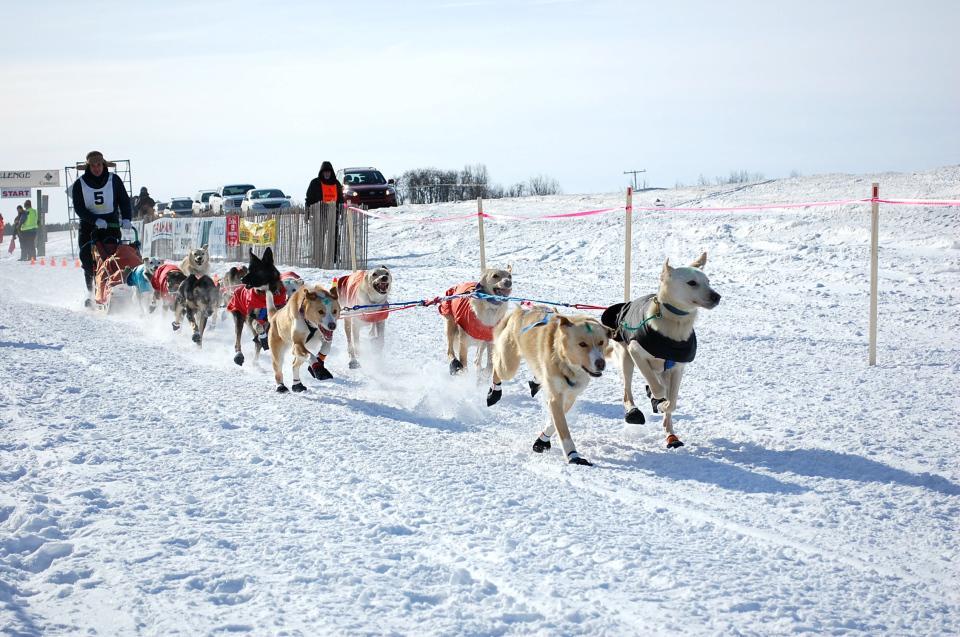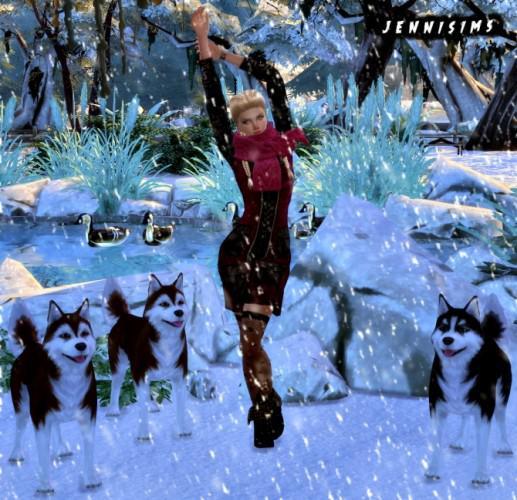The first image is the image on the left, the second image is the image on the right. Analyze the images presented: Is the assertion "One image shows a sled dog team with a standing sled driver in back moving across the snow, and the other image features at least one creature standing up on two legs." valid? Answer yes or no. Yes. The first image is the image on the left, the second image is the image on the right. For the images displayed, is the sentence "Some dogs are wearing booties." factually correct? Answer yes or no. Yes. 